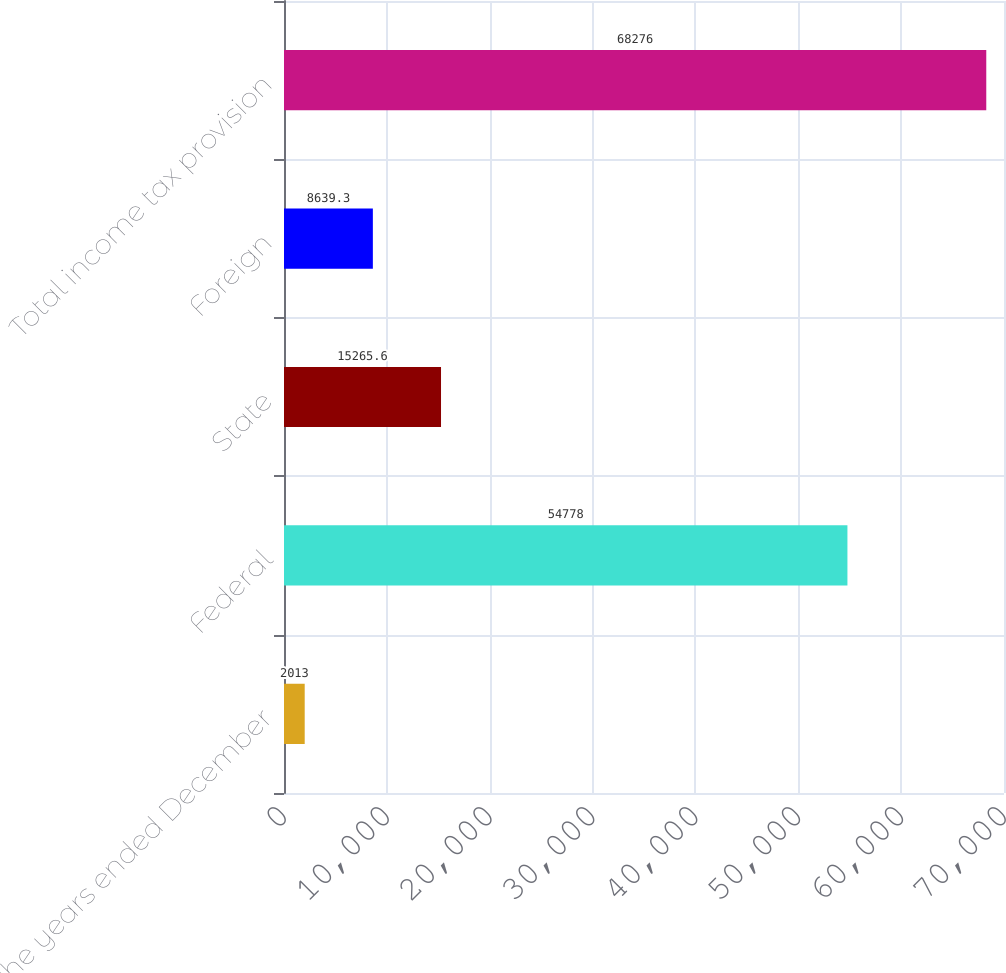<chart> <loc_0><loc_0><loc_500><loc_500><bar_chart><fcel>For the years ended December<fcel>Federal<fcel>State<fcel>Foreign<fcel>Total income tax provision<nl><fcel>2013<fcel>54778<fcel>15265.6<fcel>8639.3<fcel>68276<nl></chart> 